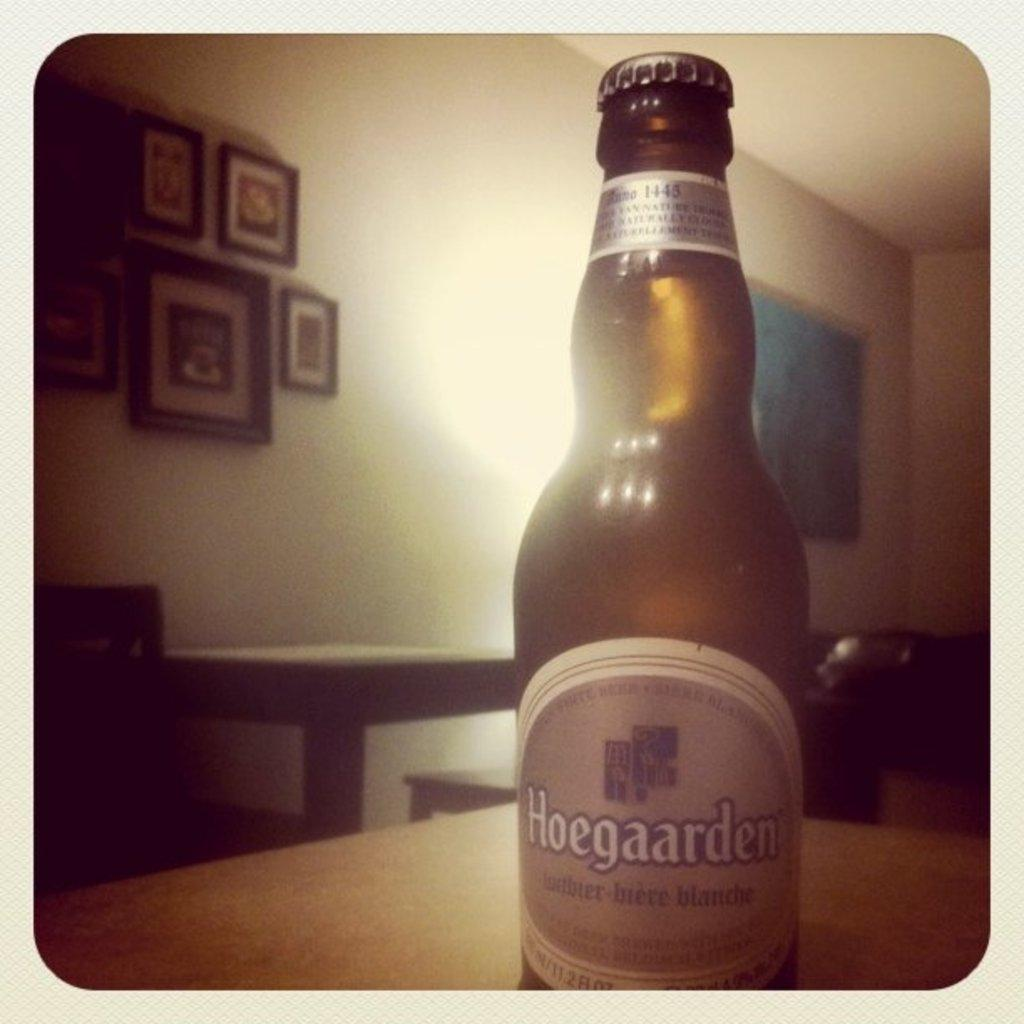<image>
Share a concise interpretation of the image provided. An amber colored glass bottle of Hoegaarden beer with a gray label with white boarder. 